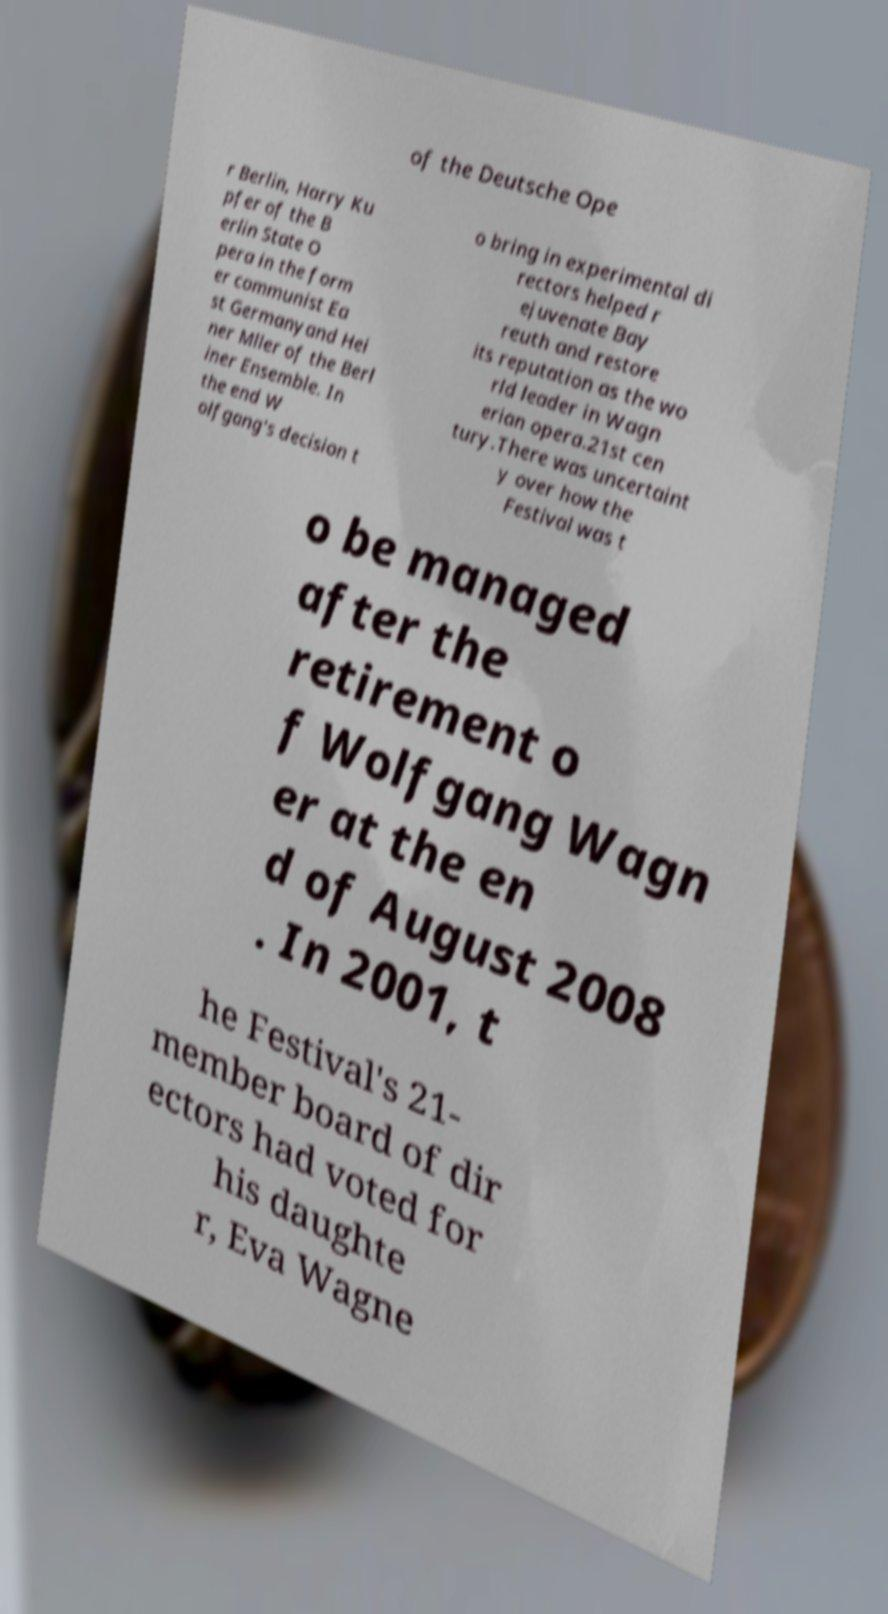I need the written content from this picture converted into text. Can you do that? of the Deutsche Ope r Berlin, Harry Ku pfer of the B erlin State O pera in the form er communist Ea st Germanyand Hei ner Mller of the Berl iner Ensemble. In the end W olfgang's decision t o bring in experimental di rectors helped r ejuvenate Bay reuth and restore its reputation as the wo rld leader in Wagn erian opera.21st cen tury.There was uncertaint y over how the Festival was t o be managed after the retirement o f Wolfgang Wagn er at the en d of August 2008 . In 2001, t he Festival's 21- member board of dir ectors had voted for his daughte r, Eva Wagne 